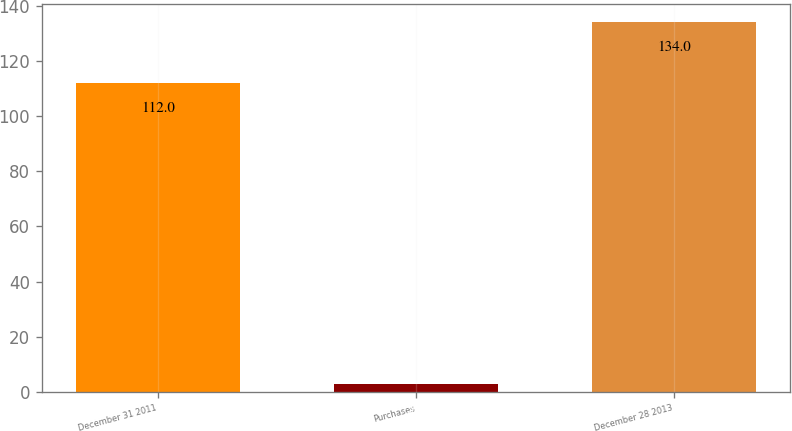Convert chart to OTSL. <chart><loc_0><loc_0><loc_500><loc_500><bar_chart><fcel>December 31 2011<fcel>Purchases<fcel>December 28 2013<nl><fcel>112<fcel>3<fcel>134<nl></chart> 